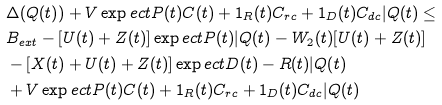Convert formula to latex. <formula><loc_0><loc_0><loc_500><loc_500>& \Delta ( Q ( t ) ) + V \exp e c t { P ( t ) C ( t ) + 1 _ { R } ( t ) C _ { r c } + 1 _ { D } ( t ) C _ { d c } | Q ( t ) } \leq \\ & B _ { e x t } - [ U ( t ) + Z ( t ) ] \exp e c t { P ( t ) | Q ( t ) } - W _ { 2 } ( t ) [ U ( t ) + Z ( t ) ] \\ & - [ X ( t ) + U ( t ) + Z ( t ) ] \exp e c t { D ( t ) - R ( t ) | Q ( t ) } \\ & + V \exp e c t { P ( t ) C ( t ) + 1 _ { R } ( t ) C _ { r c } + 1 _ { D } ( t ) C _ { d c } | Q ( t ) }</formula> 